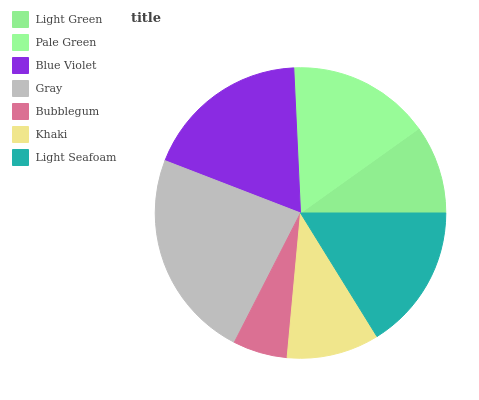Is Bubblegum the minimum?
Answer yes or no. Yes. Is Gray the maximum?
Answer yes or no. Yes. Is Pale Green the minimum?
Answer yes or no. No. Is Pale Green the maximum?
Answer yes or no. No. Is Pale Green greater than Light Green?
Answer yes or no. Yes. Is Light Green less than Pale Green?
Answer yes or no. Yes. Is Light Green greater than Pale Green?
Answer yes or no. No. Is Pale Green less than Light Green?
Answer yes or no. No. Is Pale Green the high median?
Answer yes or no. Yes. Is Pale Green the low median?
Answer yes or no. Yes. Is Gray the high median?
Answer yes or no. No. Is Blue Violet the low median?
Answer yes or no. No. 